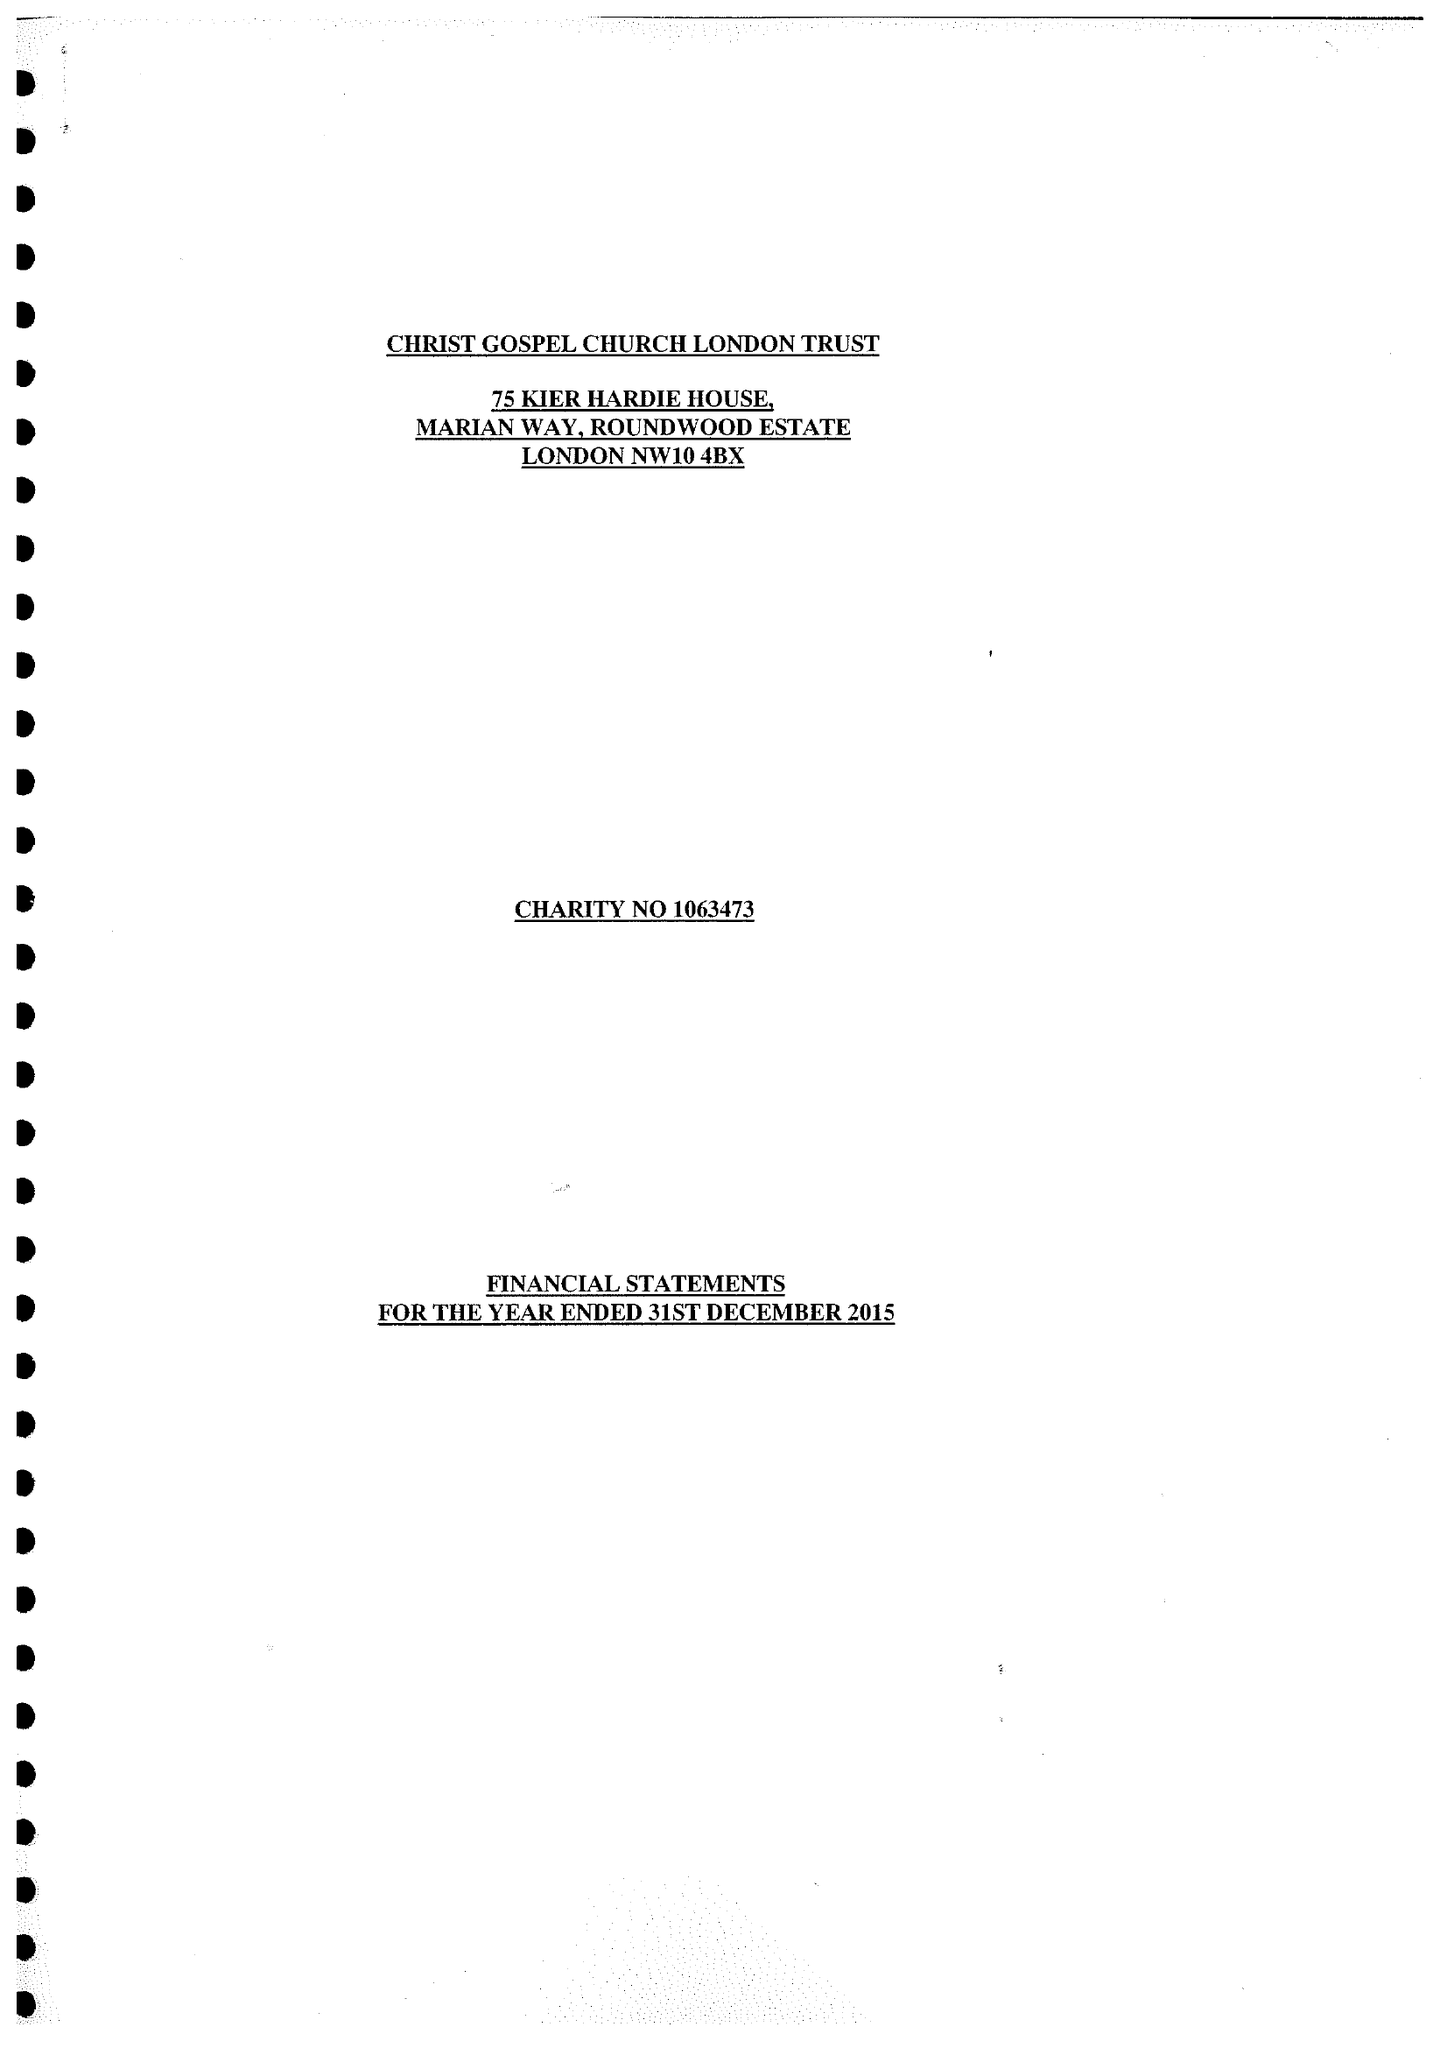What is the value for the charity_name?
Answer the question using a single word or phrase. Christ Gospel Church London Trust 